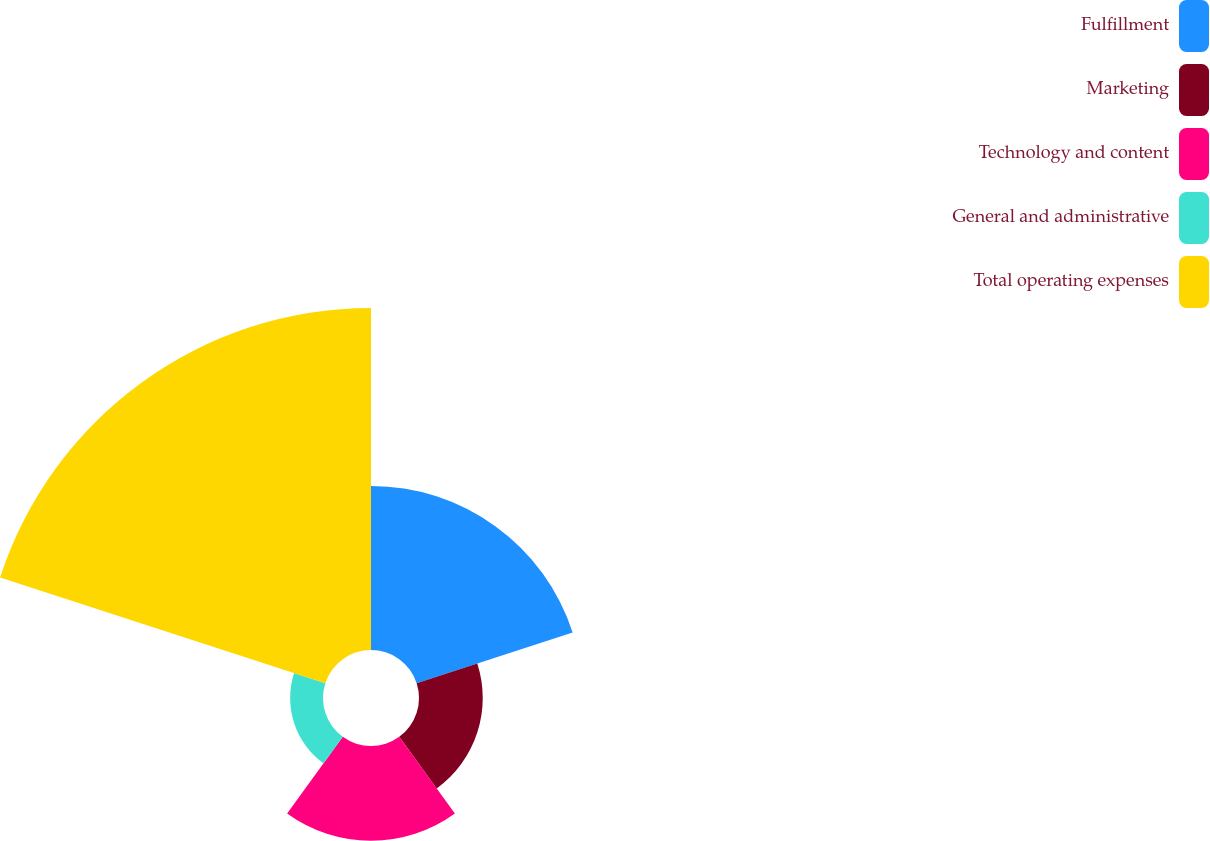Convert chart to OTSL. <chart><loc_0><loc_0><loc_500><loc_500><pie_chart><fcel>Fulfillment<fcel>Marketing<fcel>Technology and content<fcel>General and administrative<fcel>Total operating expenses<nl><fcel>23.52%<fcel>9.14%<fcel>13.58%<fcel>4.71%<fcel>49.04%<nl></chart> 